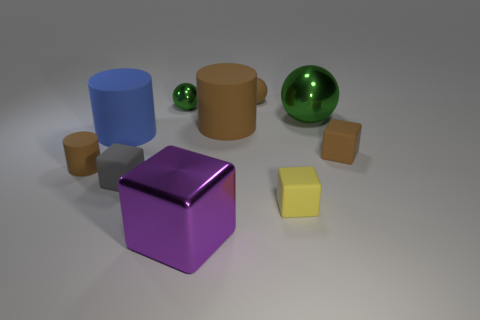Can you describe the largest object in the image? Certainly! The largest object in the image is a sizable cylinder with a calming azure hue, standing imposingly among the other geometric shapes. 